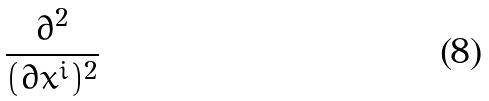Convert formula to latex. <formula><loc_0><loc_0><loc_500><loc_500>\frac { \partial ^ { 2 } } { ( \partial x ^ { i } ) ^ { 2 } }</formula> 